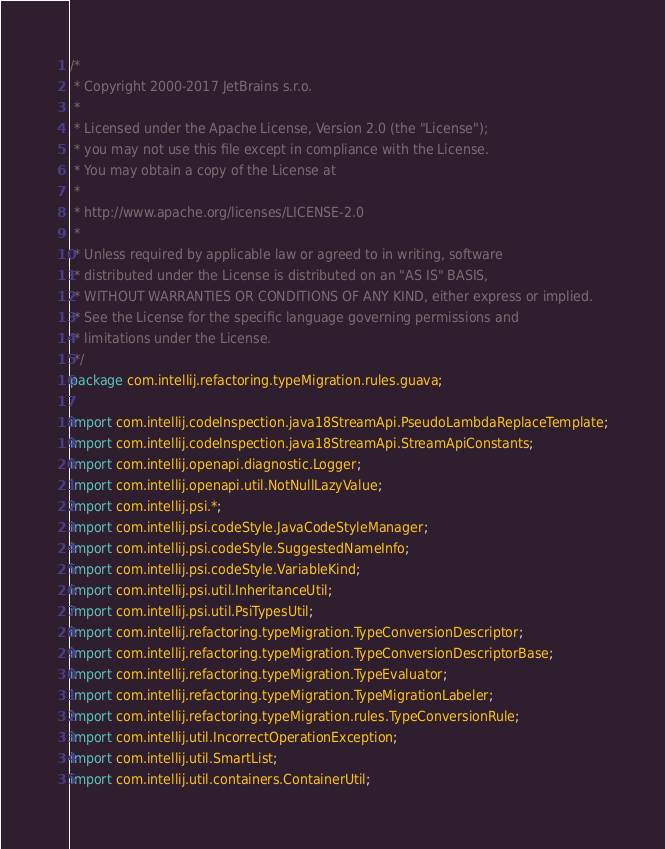<code> <loc_0><loc_0><loc_500><loc_500><_Java_>/*
 * Copyright 2000-2017 JetBrains s.r.o.
 *
 * Licensed under the Apache License, Version 2.0 (the "License");
 * you may not use this file except in compliance with the License.
 * You may obtain a copy of the License at
 *
 * http://www.apache.org/licenses/LICENSE-2.0
 *
 * Unless required by applicable law or agreed to in writing, software
 * distributed under the License is distributed on an "AS IS" BASIS,
 * WITHOUT WARRANTIES OR CONDITIONS OF ANY KIND, either express or implied.
 * See the License for the specific language governing permissions and
 * limitations under the License.
 */
package com.intellij.refactoring.typeMigration.rules.guava;

import com.intellij.codeInspection.java18StreamApi.PseudoLambdaReplaceTemplate;
import com.intellij.codeInspection.java18StreamApi.StreamApiConstants;
import com.intellij.openapi.diagnostic.Logger;
import com.intellij.openapi.util.NotNullLazyValue;
import com.intellij.psi.*;
import com.intellij.psi.codeStyle.JavaCodeStyleManager;
import com.intellij.psi.codeStyle.SuggestedNameInfo;
import com.intellij.psi.codeStyle.VariableKind;
import com.intellij.psi.util.InheritanceUtil;
import com.intellij.psi.util.PsiTypesUtil;
import com.intellij.refactoring.typeMigration.TypeConversionDescriptor;
import com.intellij.refactoring.typeMigration.TypeConversionDescriptorBase;
import com.intellij.refactoring.typeMigration.TypeEvaluator;
import com.intellij.refactoring.typeMigration.TypeMigrationLabeler;
import com.intellij.refactoring.typeMigration.rules.TypeConversionRule;
import com.intellij.util.IncorrectOperationException;
import com.intellij.util.SmartList;
import com.intellij.util.containers.ContainerUtil;</code> 